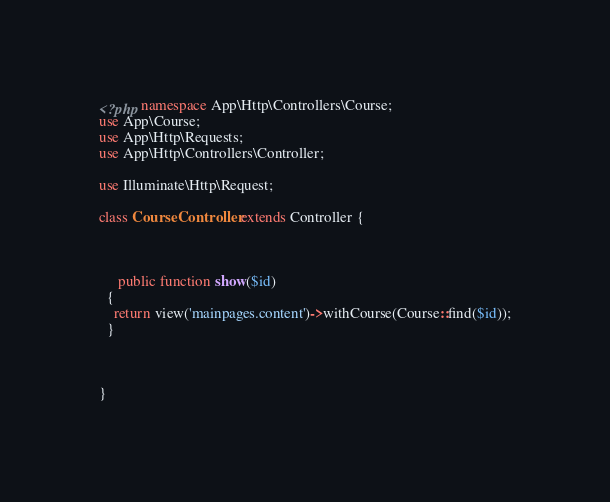Convert code to text. <code><loc_0><loc_0><loc_500><loc_500><_PHP_><?php namespace App\Http\Controllers\Course;
use App\Course;
use App\Http\Requests;
use App\Http\Controllers\Controller;

use Illuminate\Http\Request;

class CourseController extends Controller {

	
	
	 public function show($id)
  {
    return view('mainpages.content')->withCourse(Course::find($id));
  }



}</code> 